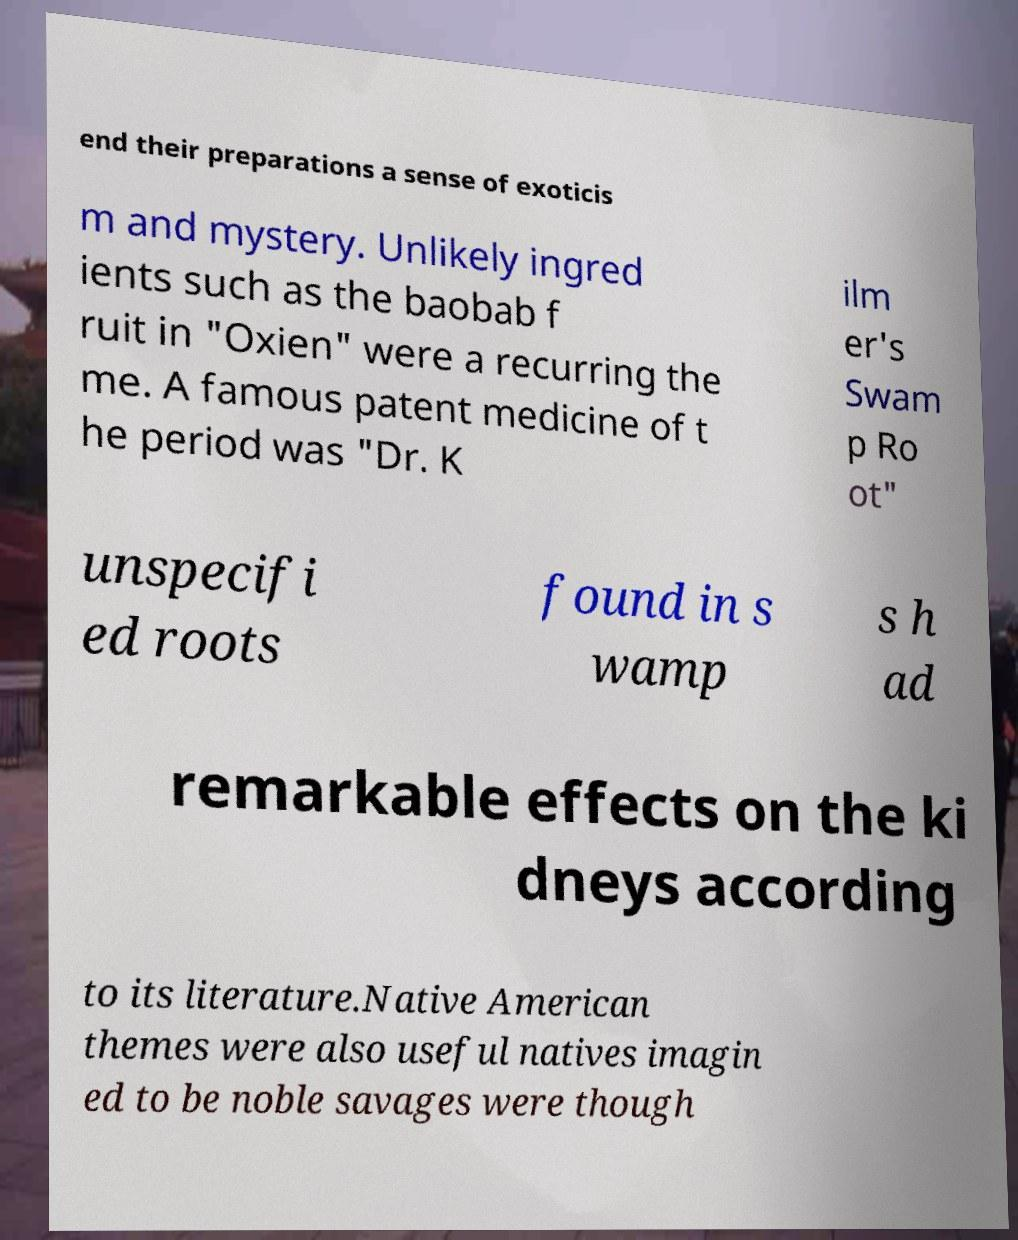Can you read and provide the text displayed in the image?This photo seems to have some interesting text. Can you extract and type it out for me? end their preparations a sense of exoticis m and mystery. Unlikely ingred ients such as the baobab f ruit in "Oxien" were a recurring the me. A famous patent medicine of t he period was "Dr. K ilm er's Swam p Ro ot" unspecifi ed roots found in s wamp s h ad remarkable effects on the ki dneys according to its literature.Native American themes were also useful natives imagin ed to be noble savages were though 